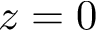Convert formula to latex. <formula><loc_0><loc_0><loc_500><loc_500>z = 0</formula> 